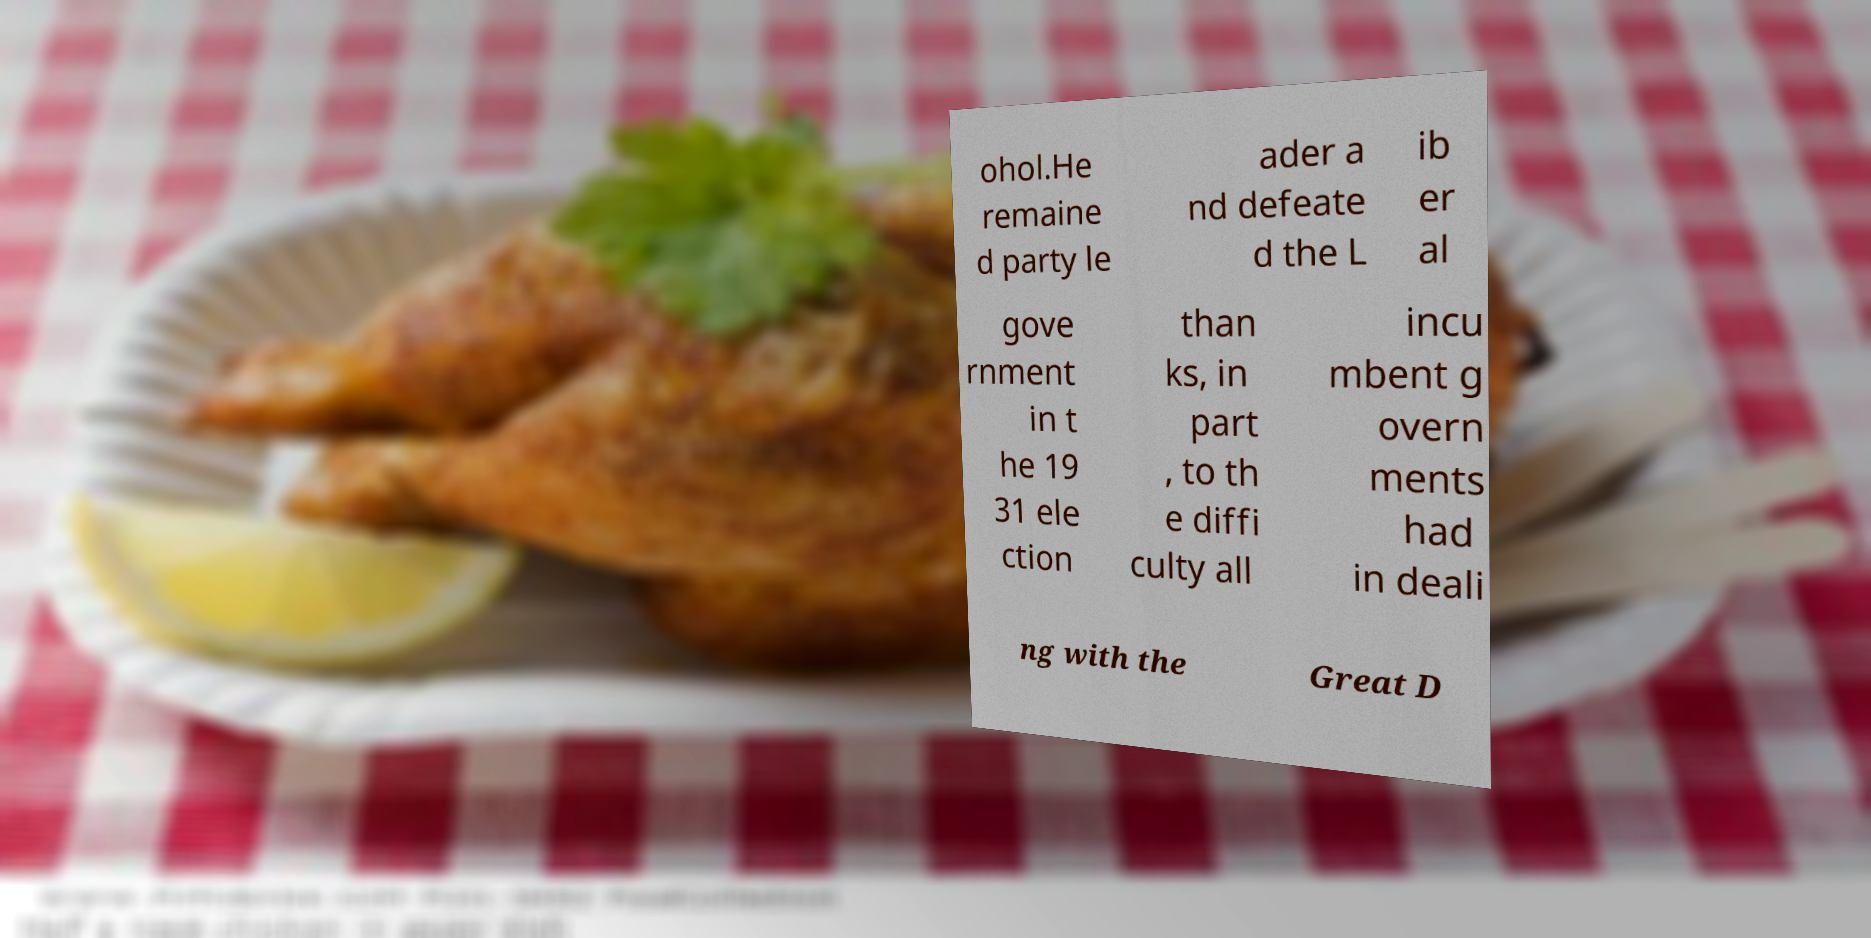Could you extract and type out the text from this image? ohol.He remaine d party le ader a nd defeate d the L ib er al gove rnment in t he 19 31 ele ction than ks, in part , to th e diffi culty all incu mbent g overn ments had in deali ng with the Great D 